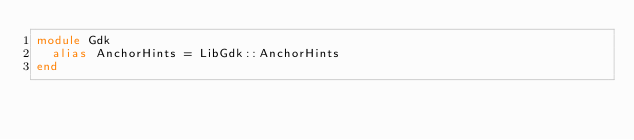<code> <loc_0><loc_0><loc_500><loc_500><_Crystal_>module Gdk
  alias AnchorHints = LibGdk::AnchorHints
end

</code> 